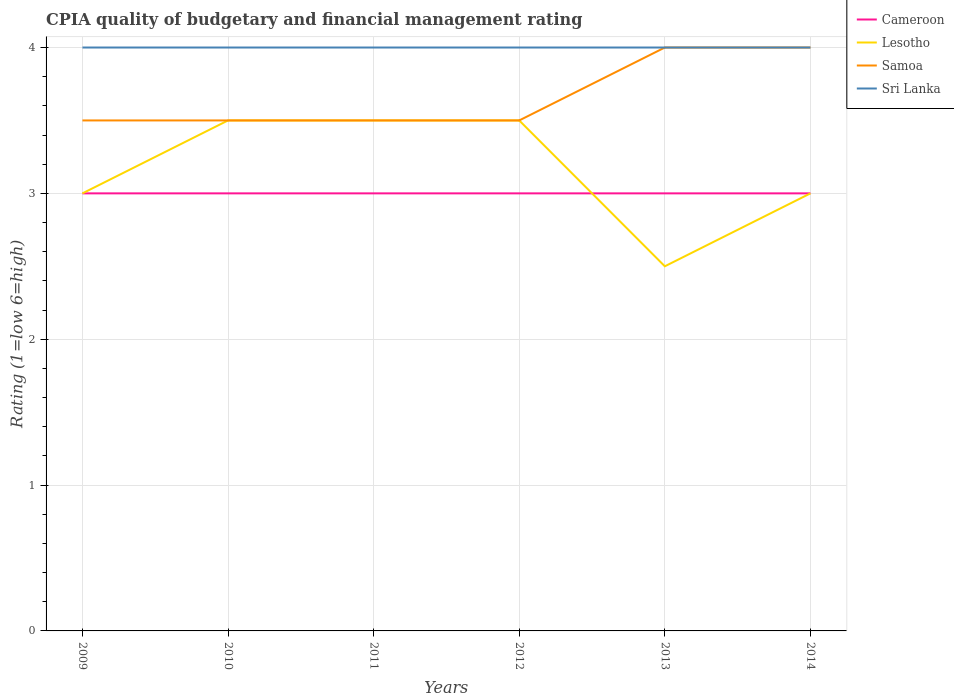How many different coloured lines are there?
Give a very brief answer. 4. Does the line corresponding to Lesotho intersect with the line corresponding to Cameroon?
Provide a succinct answer. Yes. Is the number of lines equal to the number of legend labels?
Offer a terse response. Yes. Across all years, what is the maximum CPIA rating in Sri Lanka?
Offer a terse response. 4. In which year was the CPIA rating in Lesotho maximum?
Provide a succinct answer. 2013. What is the difference between the highest and the second highest CPIA rating in Cameroon?
Offer a terse response. 0. What is the difference between two consecutive major ticks on the Y-axis?
Your answer should be very brief. 1. Where does the legend appear in the graph?
Give a very brief answer. Top right. What is the title of the graph?
Offer a terse response. CPIA quality of budgetary and financial management rating. Does "Middle East & North Africa (all income levels)" appear as one of the legend labels in the graph?
Offer a terse response. No. What is the label or title of the Y-axis?
Your answer should be very brief. Rating (1=low 6=high). What is the Rating (1=low 6=high) in Cameroon in 2009?
Offer a very short reply. 3. What is the Rating (1=low 6=high) in Cameroon in 2010?
Your answer should be very brief. 3. What is the Rating (1=low 6=high) in Lesotho in 2010?
Provide a short and direct response. 3.5. What is the Rating (1=low 6=high) of Sri Lanka in 2010?
Offer a terse response. 4. What is the Rating (1=low 6=high) in Cameroon in 2011?
Keep it short and to the point. 3. What is the Rating (1=low 6=high) in Lesotho in 2011?
Your answer should be very brief. 3.5. What is the Rating (1=low 6=high) in Samoa in 2011?
Offer a terse response. 3.5. What is the Rating (1=low 6=high) in Cameroon in 2012?
Offer a very short reply. 3. What is the Rating (1=low 6=high) of Lesotho in 2012?
Give a very brief answer. 3.5. What is the Rating (1=low 6=high) in Samoa in 2012?
Give a very brief answer. 3.5. What is the Rating (1=low 6=high) of Lesotho in 2013?
Your answer should be very brief. 2.5. What is the Rating (1=low 6=high) of Sri Lanka in 2013?
Provide a succinct answer. 4. What is the Rating (1=low 6=high) of Lesotho in 2014?
Your answer should be very brief. 3. What is the total Rating (1=low 6=high) in Lesotho in the graph?
Ensure brevity in your answer.  19. What is the difference between the Rating (1=low 6=high) in Samoa in 2009 and that in 2010?
Provide a succinct answer. 0. What is the difference between the Rating (1=low 6=high) of Cameroon in 2009 and that in 2011?
Keep it short and to the point. 0. What is the difference between the Rating (1=low 6=high) in Lesotho in 2009 and that in 2012?
Your response must be concise. -0.5. What is the difference between the Rating (1=low 6=high) in Sri Lanka in 2009 and that in 2012?
Your answer should be compact. 0. What is the difference between the Rating (1=low 6=high) of Cameroon in 2009 and that in 2013?
Your response must be concise. 0. What is the difference between the Rating (1=low 6=high) of Cameroon in 2009 and that in 2014?
Provide a short and direct response. 0. What is the difference between the Rating (1=low 6=high) in Lesotho in 2009 and that in 2014?
Provide a short and direct response. 0. What is the difference between the Rating (1=low 6=high) of Cameroon in 2010 and that in 2012?
Your answer should be compact. 0. What is the difference between the Rating (1=low 6=high) in Lesotho in 2010 and that in 2012?
Keep it short and to the point. 0. What is the difference between the Rating (1=low 6=high) of Samoa in 2010 and that in 2012?
Provide a succinct answer. 0. What is the difference between the Rating (1=low 6=high) in Sri Lanka in 2010 and that in 2012?
Offer a very short reply. 0. What is the difference between the Rating (1=low 6=high) of Samoa in 2010 and that in 2013?
Provide a succinct answer. -0.5. What is the difference between the Rating (1=low 6=high) of Sri Lanka in 2010 and that in 2013?
Provide a succinct answer. 0. What is the difference between the Rating (1=low 6=high) of Lesotho in 2010 and that in 2014?
Make the answer very short. 0.5. What is the difference between the Rating (1=low 6=high) in Samoa in 2011 and that in 2012?
Keep it short and to the point. 0. What is the difference between the Rating (1=low 6=high) of Sri Lanka in 2011 and that in 2012?
Give a very brief answer. 0. What is the difference between the Rating (1=low 6=high) in Lesotho in 2011 and that in 2013?
Offer a very short reply. 1. What is the difference between the Rating (1=low 6=high) in Samoa in 2011 and that in 2013?
Ensure brevity in your answer.  -0.5. What is the difference between the Rating (1=low 6=high) of Sri Lanka in 2012 and that in 2013?
Provide a succinct answer. 0. What is the difference between the Rating (1=low 6=high) of Lesotho in 2012 and that in 2014?
Your answer should be very brief. 0.5. What is the difference between the Rating (1=low 6=high) of Samoa in 2012 and that in 2014?
Provide a short and direct response. -0.5. What is the difference between the Rating (1=low 6=high) of Sri Lanka in 2012 and that in 2014?
Provide a short and direct response. 0. What is the difference between the Rating (1=low 6=high) of Cameroon in 2013 and that in 2014?
Your answer should be very brief. 0. What is the difference between the Rating (1=low 6=high) in Samoa in 2013 and that in 2014?
Make the answer very short. 0. What is the difference between the Rating (1=low 6=high) of Sri Lanka in 2013 and that in 2014?
Your answer should be compact. 0. What is the difference between the Rating (1=low 6=high) in Cameroon in 2009 and the Rating (1=low 6=high) in Lesotho in 2010?
Offer a terse response. -0.5. What is the difference between the Rating (1=low 6=high) of Cameroon in 2009 and the Rating (1=low 6=high) of Sri Lanka in 2010?
Make the answer very short. -1. What is the difference between the Rating (1=low 6=high) in Lesotho in 2009 and the Rating (1=low 6=high) in Sri Lanka in 2010?
Your response must be concise. -1. What is the difference between the Rating (1=low 6=high) of Cameroon in 2009 and the Rating (1=low 6=high) of Lesotho in 2011?
Your response must be concise. -0.5. What is the difference between the Rating (1=low 6=high) of Cameroon in 2009 and the Rating (1=low 6=high) of Sri Lanka in 2011?
Give a very brief answer. -1. What is the difference between the Rating (1=low 6=high) in Lesotho in 2009 and the Rating (1=low 6=high) in Samoa in 2011?
Ensure brevity in your answer.  -0.5. What is the difference between the Rating (1=low 6=high) in Lesotho in 2009 and the Rating (1=low 6=high) in Sri Lanka in 2011?
Your answer should be compact. -1. What is the difference between the Rating (1=low 6=high) in Cameroon in 2009 and the Rating (1=low 6=high) in Lesotho in 2012?
Your response must be concise. -0.5. What is the difference between the Rating (1=low 6=high) of Lesotho in 2009 and the Rating (1=low 6=high) of Samoa in 2013?
Keep it short and to the point. -1. What is the difference between the Rating (1=low 6=high) in Lesotho in 2009 and the Rating (1=low 6=high) in Sri Lanka in 2013?
Your answer should be very brief. -1. What is the difference between the Rating (1=low 6=high) of Cameroon in 2009 and the Rating (1=low 6=high) of Lesotho in 2014?
Your answer should be compact. 0. What is the difference between the Rating (1=low 6=high) of Lesotho in 2009 and the Rating (1=low 6=high) of Sri Lanka in 2014?
Provide a short and direct response. -1. What is the difference between the Rating (1=low 6=high) of Lesotho in 2010 and the Rating (1=low 6=high) of Sri Lanka in 2011?
Provide a succinct answer. -0.5. What is the difference between the Rating (1=low 6=high) of Cameroon in 2010 and the Rating (1=low 6=high) of Lesotho in 2012?
Your answer should be compact. -0.5. What is the difference between the Rating (1=low 6=high) of Cameroon in 2010 and the Rating (1=low 6=high) of Samoa in 2012?
Provide a succinct answer. -0.5. What is the difference between the Rating (1=low 6=high) of Cameroon in 2010 and the Rating (1=low 6=high) of Sri Lanka in 2012?
Ensure brevity in your answer.  -1. What is the difference between the Rating (1=low 6=high) in Samoa in 2010 and the Rating (1=low 6=high) in Sri Lanka in 2012?
Give a very brief answer. -0.5. What is the difference between the Rating (1=low 6=high) in Cameroon in 2010 and the Rating (1=low 6=high) in Lesotho in 2013?
Offer a very short reply. 0.5. What is the difference between the Rating (1=low 6=high) of Cameroon in 2010 and the Rating (1=low 6=high) of Samoa in 2013?
Ensure brevity in your answer.  -1. What is the difference between the Rating (1=low 6=high) of Cameroon in 2010 and the Rating (1=low 6=high) of Sri Lanka in 2013?
Your answer should be compact. -1. What is the difference between the Rating (1=low 6=high) in Samoa in 2010 and the Rating (1=low 6=high) in Sri Lanka in 2013?
Your answer should be very brief. -0.5. What is the difference between the Rating (1=low 6=high) of Cameroon in 2010 and the Rating (1=low 6=high) of Sri Lanka in 2014?
Provide a succinct answer. -1. What is the difference between the Rating (1=low 6=high) of Lesotho in 2010 and the Rating (1=low 6=high) of Samoa in 2014?
Your answer should be very brief. -0.5. What is the difference between the Rating (1=low 6=high) in Samoa in 2010 and the Rating (1=low 6=high) in Sri Lanka in 2014?
Ensure brevity in your answer.  -0.5. What is the difference between the Rating (1=low 6=high) of Cameroon in 2011 and the Rating (1=low 6=high) of Sri Lanka in 2012?
Your response must be concise. -1. What is the difference between the Rating (1=low 6=high) of Lesotho in 2011 and the Rating (1=low 6=high) of Sri Lanka in 2012?
Provide a succinct answer. -0.5. What is the difference between the Rating (1=low 6=high) of Cameroon in 2011 and the Rating (1=low 6=high) of Lesotho in 2013?
Your response must be concise. 0.5. What is the difference between the Rating (1=low 6=high) of Lesotho in 2011 and the Rating (1=low 6=high) of Sri Lanka in 2013?
Keep it short and to the point. -0.5. What is the difference between the Rating (1=low 6=high) in Cameroon in 2011 and the Rating (1=low 6=high) in Sri Lanka in 2014?
Offer a very short reply. -1. What is the difference between the Rating (1=low 6=high) of Lesotho in 2011 and the Rating (1=low 6=high) of Sri Lanka in 2014?
Keep it short and to the point. -0.5. What is the difference between the Rating (1=low 6=high) of Cameroon in 2012 and the Rating (1=low 6=high) of Sri Lanka in 2013?
Your answer should be very brief. -1. What is the difference between the Rating (1=low 6=high) of Lesotho in 2012 and the Rating (1=low 6=high) of Samoa in 2013?
Offer a terse response. -0.5. What is the difference between the Rating (1=low 6=high) in Lesotho in 2012 and the Rating (1=low 6=high) in Sri Lanka in 2013?
Your response must be concise. -0.5. What is the difference between the Rating (1=low 6=high) in Cameroon in 2012 and the Rating (1=low 6=high) in Lesotho in 2014?
Provide a succinct answer. 0. What is the difference between the Rating (1=low 6=high) in Cameroon in 2012 and the Rating (1=low 6=high) in Sri Lanka in 2014?
Your response must be concise. -1. What is the difference between the Rating (1=low 6=high) of Samoa in 2012 and the Rating (1=low 6=high) of Sri Lanka in 2014?
Your answer should be very brief. -0.5. What is the difference between the Rating (1=low 6=high) of Cameroon in 2013 and the Rating (1=low 6=high) of Lesotho in 2014?
Offer a very short reply. 0. What is the difference between the Rating (1=low 6=high) of Cameroon in 2013 and the Rating (1=low 6=high) of Sri Lanka in 2014?
Your answer should be compact. -1. What is the difference between the Rating (1=low 6=high) in Lesotho in 2013 and the Rating (1=low 6=high) in Sri Lanka in 2014?
Offer a terse response. -1.5. What is the difference between the Rating (1=low 6=high) of Samoa in 2013 and the Rating (1=low 6=high) of Sri Lanka in 2014?
Provide a short and direct response. 0. What is the average Rating (1=low 6=high) of Cameroon per year?
Provide a short and direct response. 3. What is the average Rating (1=low 6=high) in Lesotho per year?
Offer a terse response. 3.17. What is the average Rating (1=low 6=high) of Samoa per year?
Give a very brief answer. 3.67. What is the average Rating (1=low 6=high) of Sri Lanka per year?
Offer a very short reply. 4. In the year 2009, what is the difference between the Rating (1=low 6=high) of Cameroon and Rating (1=low 6=high) of Lesotho?
Your answer should be compact. 0. In the year 2009, what is the difference between the Rating (1=low 6=high) in Cameroon and Rating (1=low 6=high) in Sri Lanka?
Keep it short and to the point. -1. In the year 2009, what is the difference between the Rating (1=low 6=high) of Lesotho and Rating (1=low 6=high) of Samoa?
Your answer should be compact. -0.5. In the year 2009, what is the difference between the Rating (1=low 6=high) in Lesotho and Rating (1=low 6=high) in Sri Lanka?
Ensure brevity in your answer.  -1. In the year 2010, what is the difference between the Rating (1=low 6=high) of Cameroon and Rating (1=low 6=high) of Sri Lanka?
Your response must be concise. -1. In the year 2010, what is the difference between the Rating (1=low 6=high) of Lesotho and Rating (1=low 6=high) of Sri Lanka?
Keep it short and to the point. -0.5. In the year 2010, what is the difference between the Rating (1=low 6=high) in Samoa and Rating (1=low 6=high) in Sri Lanka?
Provide a succinct answer. -0.5. In the year 2011, what is the difference between the Rating (1=low 6=high) in Cameroon and Rating (1=low 6=high) in Lesotho?
Your answer should be compact. -0.5. In the year 2011, what is the difference between the Rating (1=low 6=high) in Lesotho and Rating (1=low 6=high) in Samoa?
Give a very brief answer. 0. In the year 2011, what is the difference between the Rating (1=low 6=high) of Samoa and Rating (1=low 6=high) of Sri Lanka?
Offer a terse response. -0.5. In the year 2012, what is the difference between the Rating (1=low 6=high) in Lesotho and Rating (1=low 6=high) in Sri Lanka?
Offer a terse response. -0.5. In the year 2012, what is the difference between the Rating (1=low 6=high) of Samoa and Rating (1=low 6=high) of Sri Lanka?
Keep it short and to the point. -0.5. In the year 2013, what is the difference between the Rating (1=low 6=high) of Cameroon and Rating (1=low 6=high) of Lesotho?
Give a very brief answer. 0.5. In the year 2014, what is the difference between the Rating (1=low 6=high) of Cameroon and Rating (1=low 6=high) of Samoa?
Keep it short and to the point. -1. In the year 2014, what is the difference between the Rating (1=low 6=high) of Lesotho and Rating (1=low 6=high) of Sri Lanka?
Offer a terse response. -1. What is the ratio of the Rating (1=low 6=high) of Samoa in 2009 to that in 2010?
Keep it short and to the point. 1. What is the ratio of the Rating (1=low 6=high) of Lesotho in 2009 to that in 2011?
Make the answer very short. 0.86. What is the ratio of the Rating (1=low 6=high) of Samoa in 2009 to that in 2011?
Your answer should be very brief. 1. What is the ratio of the Rating (1=low 6=high) in Sri Lanka in 2009 to that in 2011?
Offer a terse response. 1. What is the ratio of the Rating (1=low 6=high) of Cameroon in 2009 to that in 2012?
Ensure brevity in your answer.  1. What is the ratio of the Rating (1=low 6=high) of Cameroon in 2009 to that in 2013?
Your response must be concise. 1. What is the ratio of the Rating (1=low 6=high) in Samoa in 2009 to that in 2013?
Give a very brief answer. 0.88. What is the ratio of the Rating (1=low 6=high) in Samoa in 2009 to that in 2014?
Provide a short and direct response. 0.88. What is the ratio of the Rating (1=low 6=high) in Sri Lanka in 2009 to that in 2014?
Provide a short and direct response. 1. What is the ratio of the Rating (1=low 6=high) of Cameroon in 2010 to that in 2011?
Provide a succinct answer. 1. What is the ratio of the Rating (1=low 6=high) of Lesotho in 2010 to that in 2011?
Your answer should be very brief. 1. What is the ratio of the Rating (1=low 6=high) of Samoa in 2010 to that in 2011?
Offer a very short reply. 1. What is the ratio of the Rating (1=low 6=high) of Cameroon in 2010 to that in 2012?
Your answer should be very brief. 1. What is the ratio of the Rating (1=low 6=high) of Lesotho in 2010 to that in 2013?
Your answer should be compact. 1.4. What is the ratio of the Rating (1=low 6=high) of Sri Lanka in 2010 to that in 2013?
Offer a very short reply. 1. What is the ratio of the Rating (1=low 6=high) in Samoa in 2010 to that in 2014?
Provide a short and direct response. 0.88. What is the ratio of the Rating (1=low 6=high) of Cameroon in 2011 to that in 2012?
Make the answer very short. 1. What is the ratio of the Rating (1=low 6=high) of Samoa in 2011 to that in 2012?
Provide a short and direct response. 1. What is the ratio of the Rating (1=low 6=high) of Cameroon in 2011 to that in 2013?
Keep it short and to the point. 1. What is the ratio of the Rating (1=low 6=high) in Lesotho in 2011 to that in 2013?
Offer a very short reply. 1.4. What is the ratio of the Rating (1=low 6=high) of Samoa in 2011 to that in 2013?
Offer a terse response. 0.88. What is the ratio of the Rating (1=low 6=high) in Sri Lanka in 2011 to that in 2013?
Provide a succinct answer. 1. What is the ratio of the Rating (1=low 6=high) in Cameroon in 2012 to that in 2013?
Make the answer very short. 1. What is the ratio of the Rating (1=low 6=high) in Sri Lanka in 2012 to that in 2013?
Offer a terse response. 1. What is the ratio of the Rating (1=low 6=high) in Sri Lanka in 2012 to that in 2014?
Provide a short and direct response. 1. What is the ratio of the Rating (1=low 6=high) of Cameroon in 2013 to that in 2014?
Offer a very short reply. 1. What is the ratio of the Rating (1=low 6=high) of Sri Lanka in 2013 to that in 2014?
Offer a very short reply. 1. What is the difference between the highest and the second highest Rating (1=low 6=high) of Lesotho?
Make the answer very short. 0. What is the difference between the highest and the second highest Rating (1=low 6=high) in Samoa?
Your answer should be very brief. 0. What is the difference between the highest and the lowest Rating (1=low 6=high) of Cameroon?
Offer a terse response. 0. What is the difference between the highest and the lowest Rating (1=low 6=high) in Samoa?
Offer a very short reply. 0.5. What is the difference between the highest and the lowest Rating (1=low 6=high) of Sri Lanka?
Your answer should be very brief. 0. 